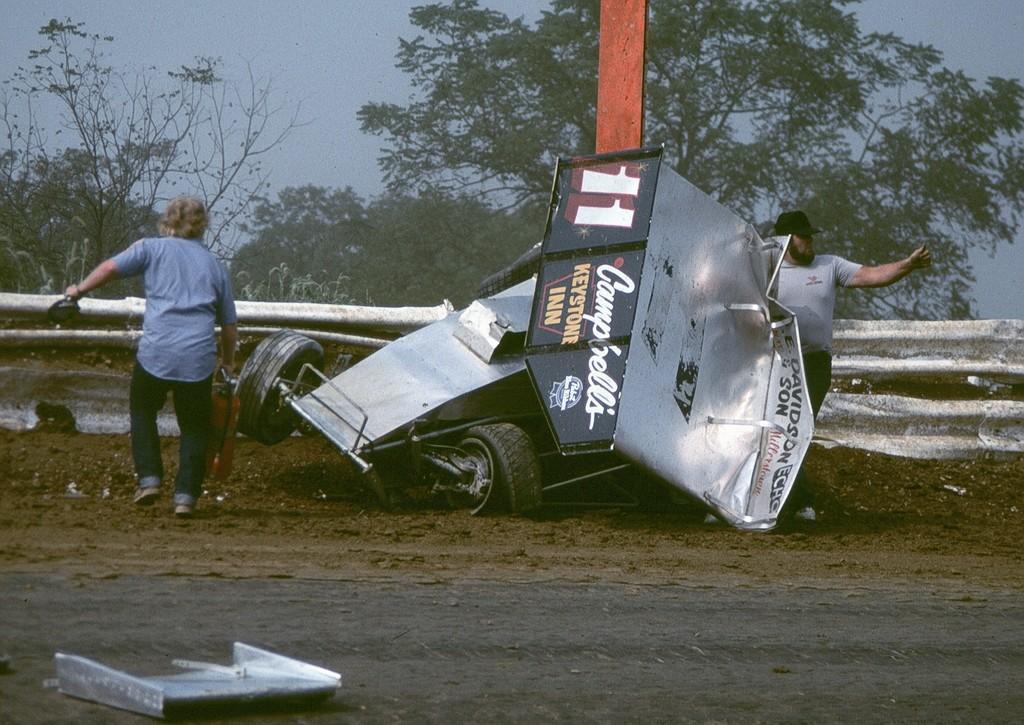Describe this image in one or two sentences. In this picture I can observe a crashed vehicle. There are two members on either sides of this vehicle. Behind the vehicle there is a railing. I can observe road in front of the vehicle. In the background there are trees and a sky. 